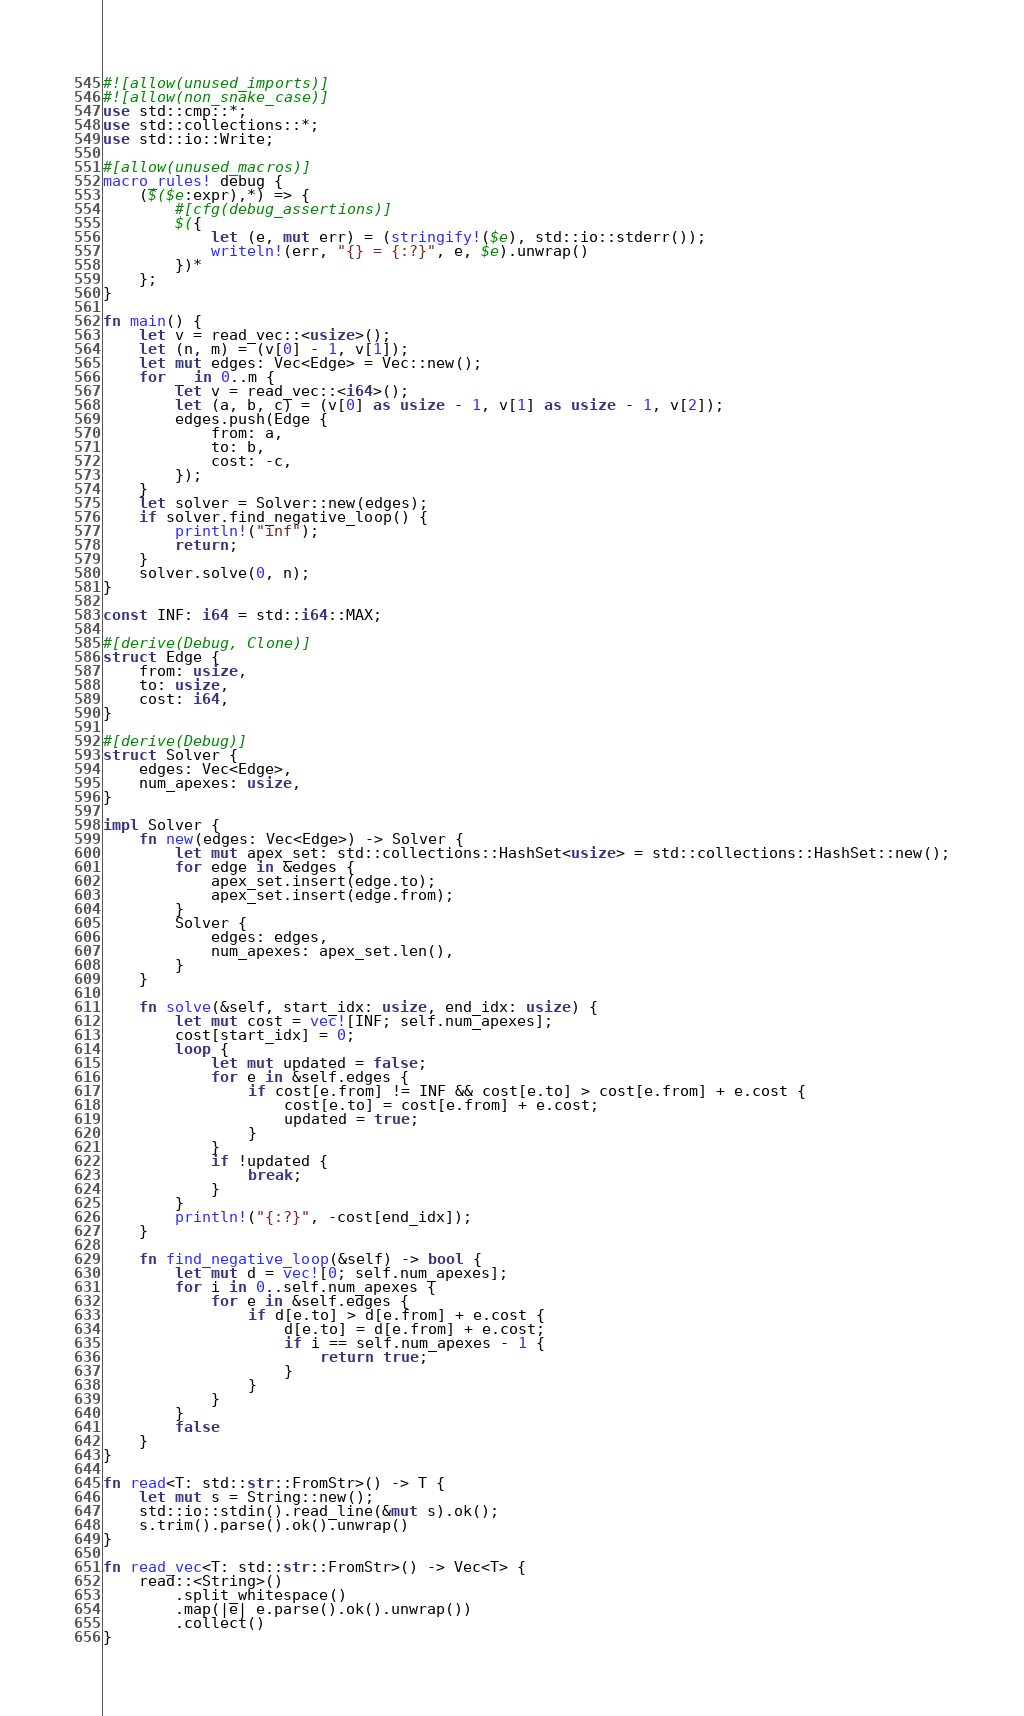<code> <loc_0><loc_0><loc_500><loc_500><_Rust_>#![allow(unused_imports)]
#![allow(non_snake_case)]
use std::cmp::*;
use std::collections::*;
use std::io::Write;

#[allow(unused_macros)]
macro_rules! debug {
    ($($e:expr),*) => {
        #[cfg(debug_assertions)]
        $({
            let (e, mut err) = (stringify!($e), std::io::stderr());
            writeln!(err, "{} = {:?}", e, $e).unwrap()
        })*
    };
}

fn main() {
    let v = read_vec::<usize>();
    let (n, m) = (v[0] - 1, v[1]);
    let mut edges: Vec<Edge> = Vec::new();
    for _ in 0..m {
        let v = read_vec::<i64>();
        let (a, b, c) = (v[0] as usize - 1, v[1] as usize - 1, v[2]);
        edges.push(Edge {
            from: a,
            to: b,
            cost: -c,
        });
    }
    let solver = Solver::new(edges);
    if solver.find_negative_loop() {
        println!("inf");
        return;
    }
    solver.solve(0, n);
}

const INF: i64 = std::i64::MAX;

#[derive(Debug, Clone)]
struct Edge {
    from: usize,
    to: usize,
    cost: i64,
}

#[derive(Debug)]
struct Solver {
    edges: Vec<Edge>,
    num_apexes: usize,
}

impl Solver {
    fn new(edges: Vec<Edge>) -> Solver {
        let mut apex_set: std::collections::HashSet<usize> = std::collections::HashSet::new();
        for edge in &edges {
            apex_set.insert(edge.to);
            apex_set.insert(edge.from);
        }
        Solver {
            edges: edges,
            num_apexes: apex_set.len(),
        }
    }

    fn solve(&self, start_idx: usize, end_idx: usize) {
        let mut cost = vec![INF; self.num_apexes];
        cost[start_idx] = 0;
        loop {
            let mut updated = false;
            for e in &self.edges {
                if cost[e.from] != INF && cost[e.to] > cost[e.from] + e.cost {
                    cost[e.to] = cost[e.from] + e.cost;
                    updated = true;
                }
            }
            if !updated {
                break;
            }
        }
        println!("{:?}", -cost[end_idx]);
    }

    fn find_negative_loop(&self) -> bool {
        let mut d = vec![0; self.num_apexes];
        for i in 0..self.num_apexes {
            for e in &self.edges {
                if d[e.to] > d[e.from] + e.cost {
                    d[e.to] = d[e.from] + e.cost;
                    if i == self.num_apexes - 1 {
                        return true;
                    }
                }
            }
        }
        false
    }
}

fn read<T: std::str::FromStr>() -> T {
    let mut s = String::new();
    std::io::stdin().read_line(&mut s).ok();
    s.trim().parse().ok().unwrap()
}

fn read_vec<T: std::str::FromStr>() -> Vec<T> {
    read::<String>()
        .split_whitespace()
        .map(|e| e.parse().ok().unwrap())
        .collect()
}
</code> 